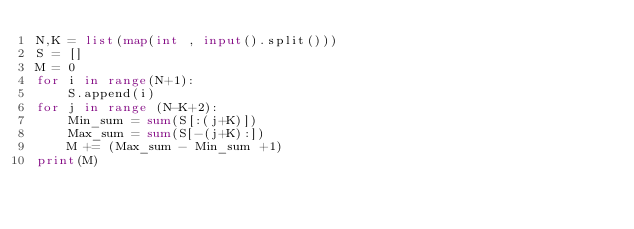Convert code to text. <code><loc_0><loc_0><loc_500><loc_500><_Python_>N,K = list(map(int , input().split()))
S = []
M = 0
for i in range(N+1):
    S.append(i)
for j in range (N-K+2):
    Min_sum = sum(S[:(j+K)])
    Max_sum = sum(S[-(j+K):])
    M += (Max_sum - Min_sum +1)
print(M)</code> 